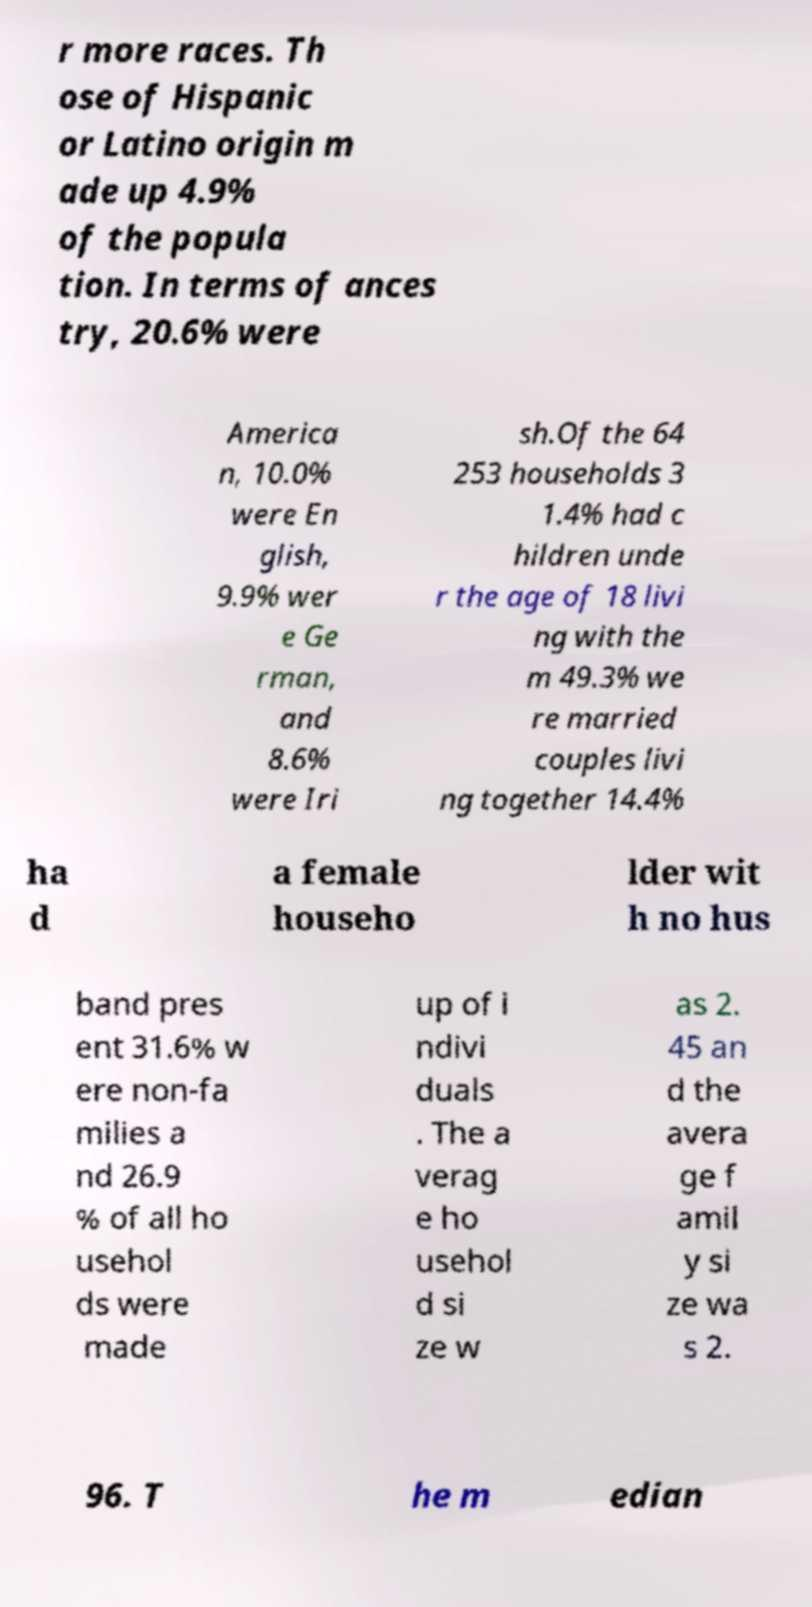Could you extract and type out the text from this image? r more races. Th ose of Hispanic or Latino origin m ade up 4.9% of the popula tion. In terms of ances try, 20.6% were America n, 10.0% were En glish, 9.9% wer e Ge rman, and 8.6% were Iri sh.Of the 64 253 households 3 1.4% had c hildren unde r the age of 18 livi ng with the m 49.3% we re married couples livi ng together 14.4% ha d a female househo lder wit h no hus band pres ent 31.6% w ere non-fa milies a nd 26.9 % of all ho usehol ds were made up of i ndivi duals . The a verag e ho usehol d si ze w as 2. 45 an d the avera ge f amil y si ze wa s 2. 96. T he m edian 